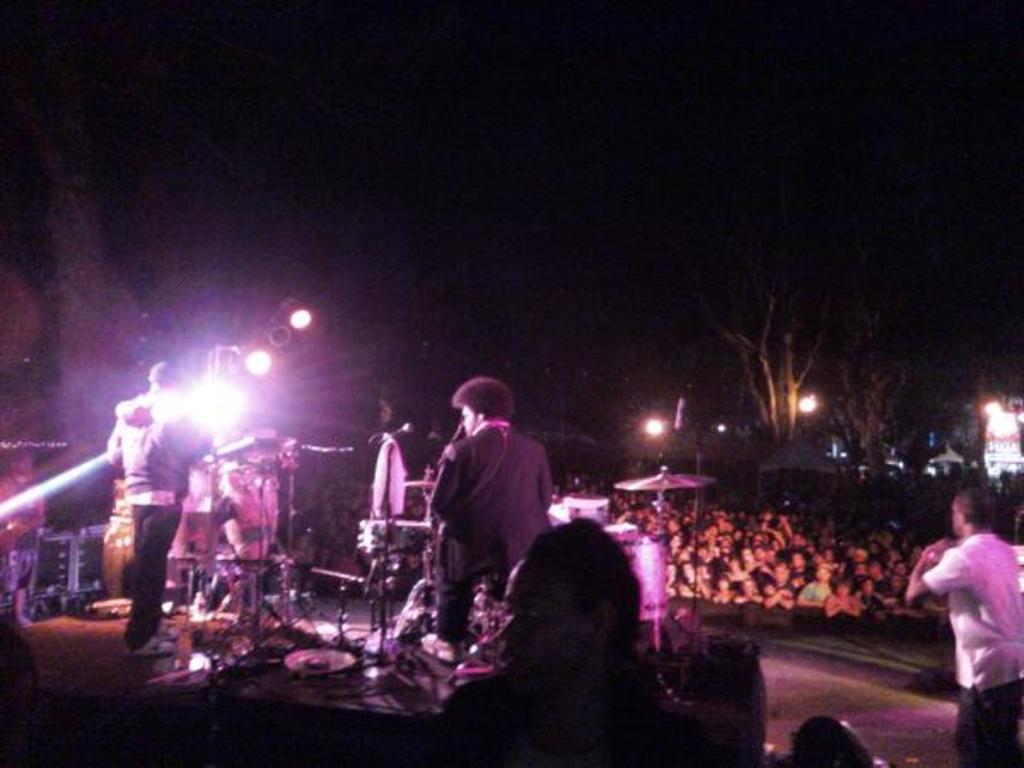How would you summarize this image in a sentence or two? There are persons standing on a stage on which, there is a person, there are musical instruments and speakers. On the right side, there is a person in white color t-shirt standing. In the background, there are persons and lights. And the background is dark in color. 